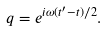Convert formula to latex. <formula><loc_0><loc_0><loc_500><loc_500>q = e ^ { i \omega ( t ^ { \prime } - t ) / 2 } .</formula> 